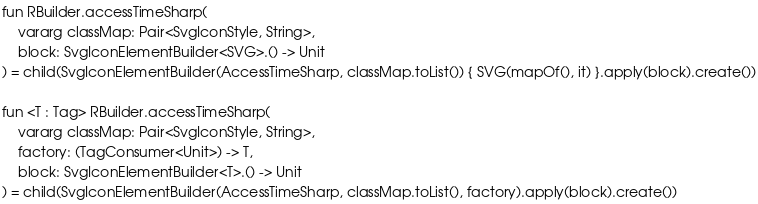Convert code to text. <code><loc_0><loc_0><loc_500><loc_500><_Kotlin_>
fun RBuilder.accessTimeSharp(
    vararg classMap: Pair<SvgIconStyle, String>,
    block: SvgIconElementBuilder<SVG>.() -> Unit
) = child(SvgIconElementBuilder(AccessTimeSharp, classMap.toList()) { SVG(mapOf(), it) }.apply(block).create())

fun <T : Tag> RBuilder.accessTimeSharp(
    vararg classMap: Pair<SvgIconStyle, String>,
    factory: (TagConsumer<Unit>) -> T,
    block: SvgIconElementBuilder<T>.() -> Unit
) = child(SvgIconElementBuilder(AccessTimeSharp, classMap.toList(), factory).apply(block).create())
</code> 